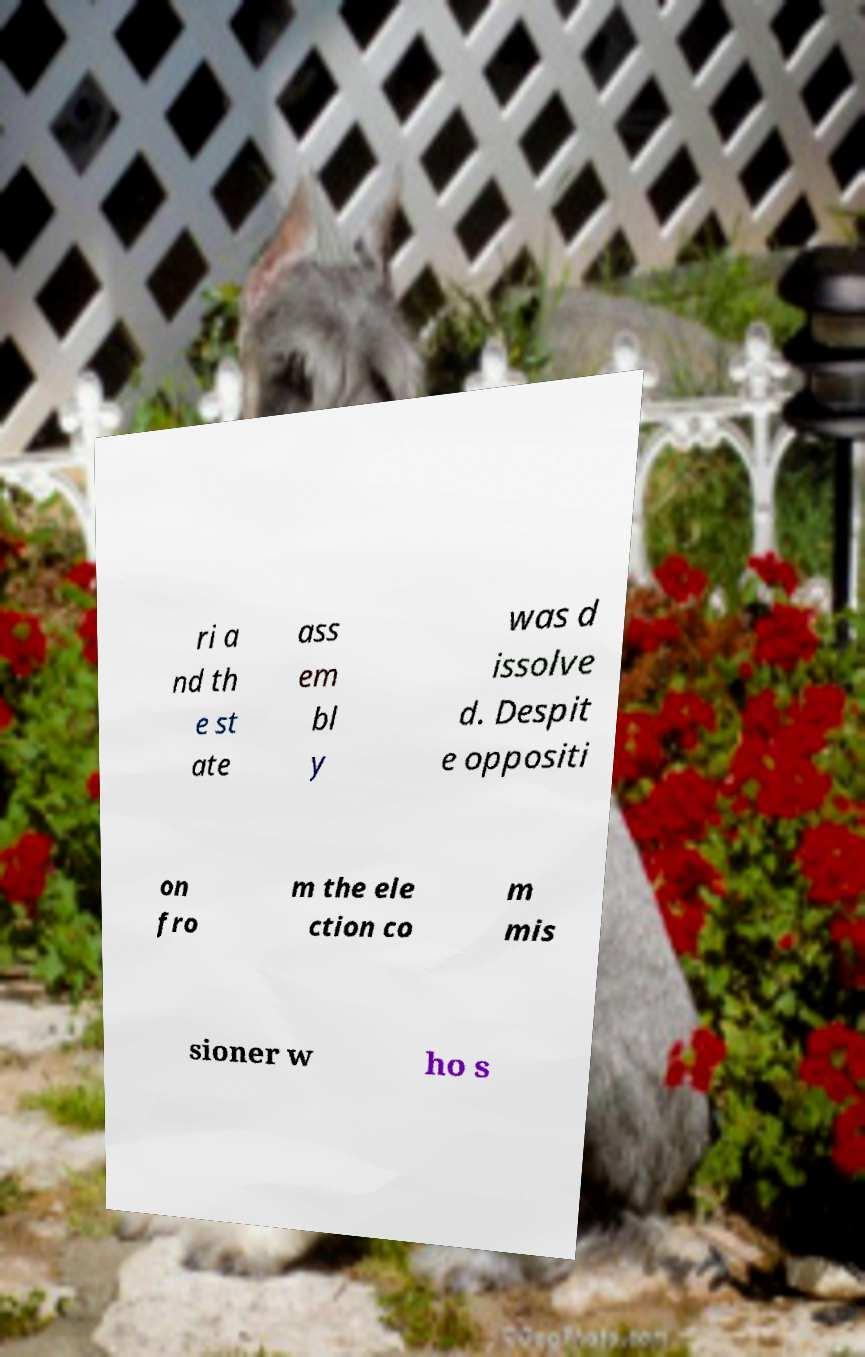I need the written content from this picture converted into text. Can you do that? ri a nd th e st ate ass em bl y was d issolve d. Despit e oppositi on fro m the ele ction co m mis sioner w ho s 